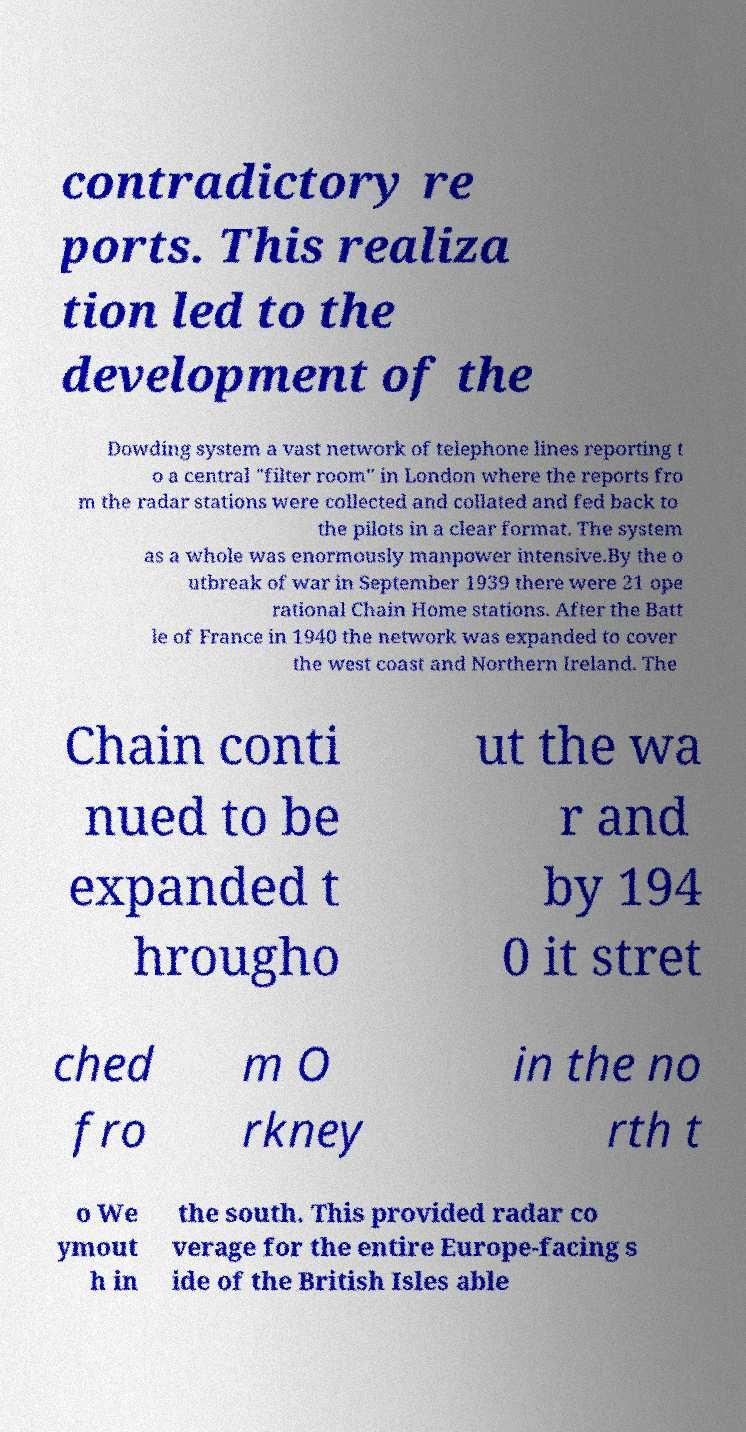For documentation purposes, I need the text within this image transcribed. Could you provide that? contradictory re ports. This realiza tion led to the development of the Dowding system a vast network of telephone lines reporting t o a central "filter room" in London where the reports fro m the radar stations were collected and collated and fed back to the pilots in a clear format. The system as a whole was enormously manpower intensive.By the o utbreak of war in September 1939 there were 21 ope rational Chain Home stations. After the Batt le of France in 1940 the network was expanded to cover the west coast and Northern Ireland. The Chain conti nued to be expanded t hrougho ut the wa r and by 194 0 it stret ched fro m O rkney in the no rth t o We ymout h in the south. This provided radar co verage for the entire Europe-facing s ide of the British Isles able 